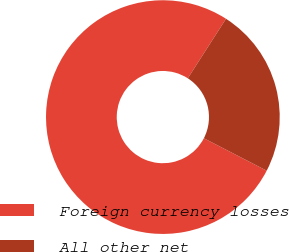Convert chart. <chart><loc_0><loc_0><loc_500><loc_500><pie_chart><fcel>Foreign currency losses<fcel>All other net<nl><fcel>76.5%<fcel>23.5%<nl></chart> 